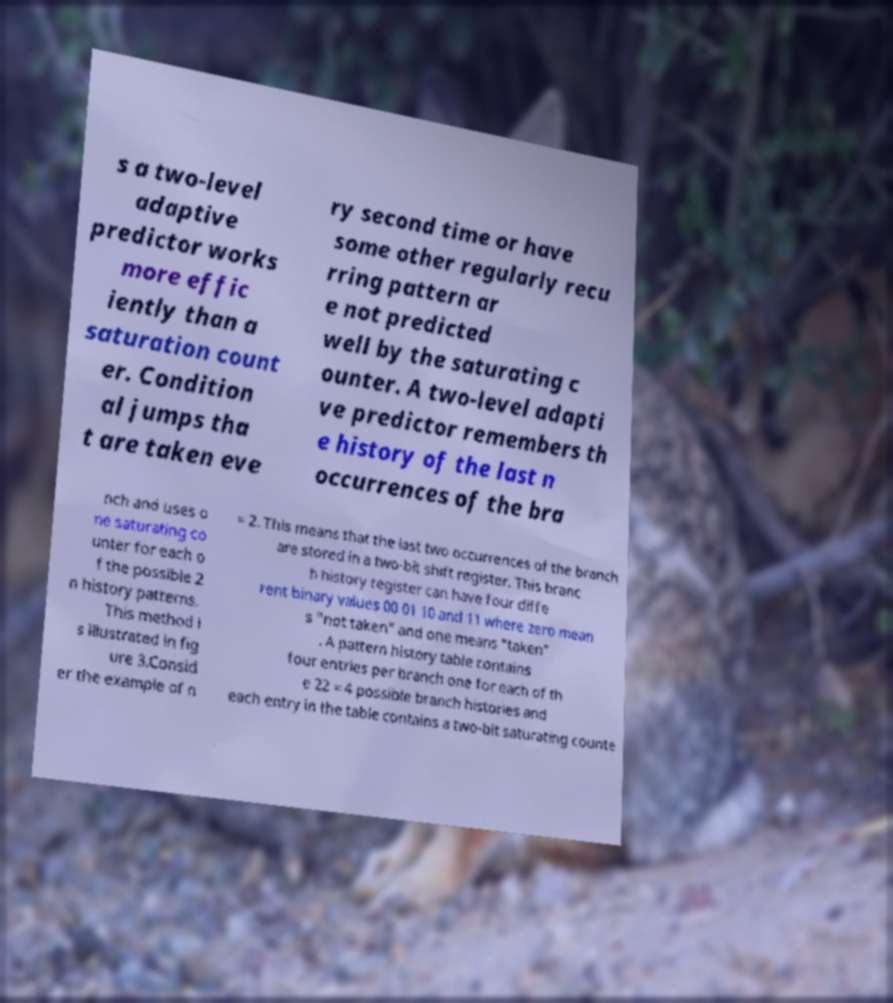Could you extract and type out the text from this image? s a two-level adaptive predictor works more effic iently than a saturation count er. Condition al jumps tha t are taken eve ry second time or have some other regularly recu rring pattern ar e not predicted well by the saturating c ounter. A two-level adapti ve predictor remembers th e history of the last n occurrences of the bra nch and uses o ne saturating co unter for each o f the possible 2 n history patterns. This method i s illustrated in fig ure 3.Consid er the example of n = 2. This means that the last two occurrences of the branch are stored in a two-bit shift register. This branc h history register can have four diffe rent binary values 00 01 10 and 11 where zero mean s "not taken" and one means "taken" . A pattern history table contains four entries per branch one for each of th e 22 = 4 possible branch histories and each entry in the table contains a two-bit saturating counte 